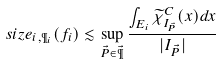Convert formula to latex. <formula><loc_0><loc_0><loc_500><loc_500>\ s i z e _ { i , \P _ { i } } ( f _ { i } ) \lesssim \sup _ { \vec { P } \in \vec { \P } } \frac { \int _ { E _ { i } } \widetilde { \chi } _ { I _ { \vec { P } } } ^ { C } ( x ) d x } { | I _ { \vec { P } } | }</formula> 